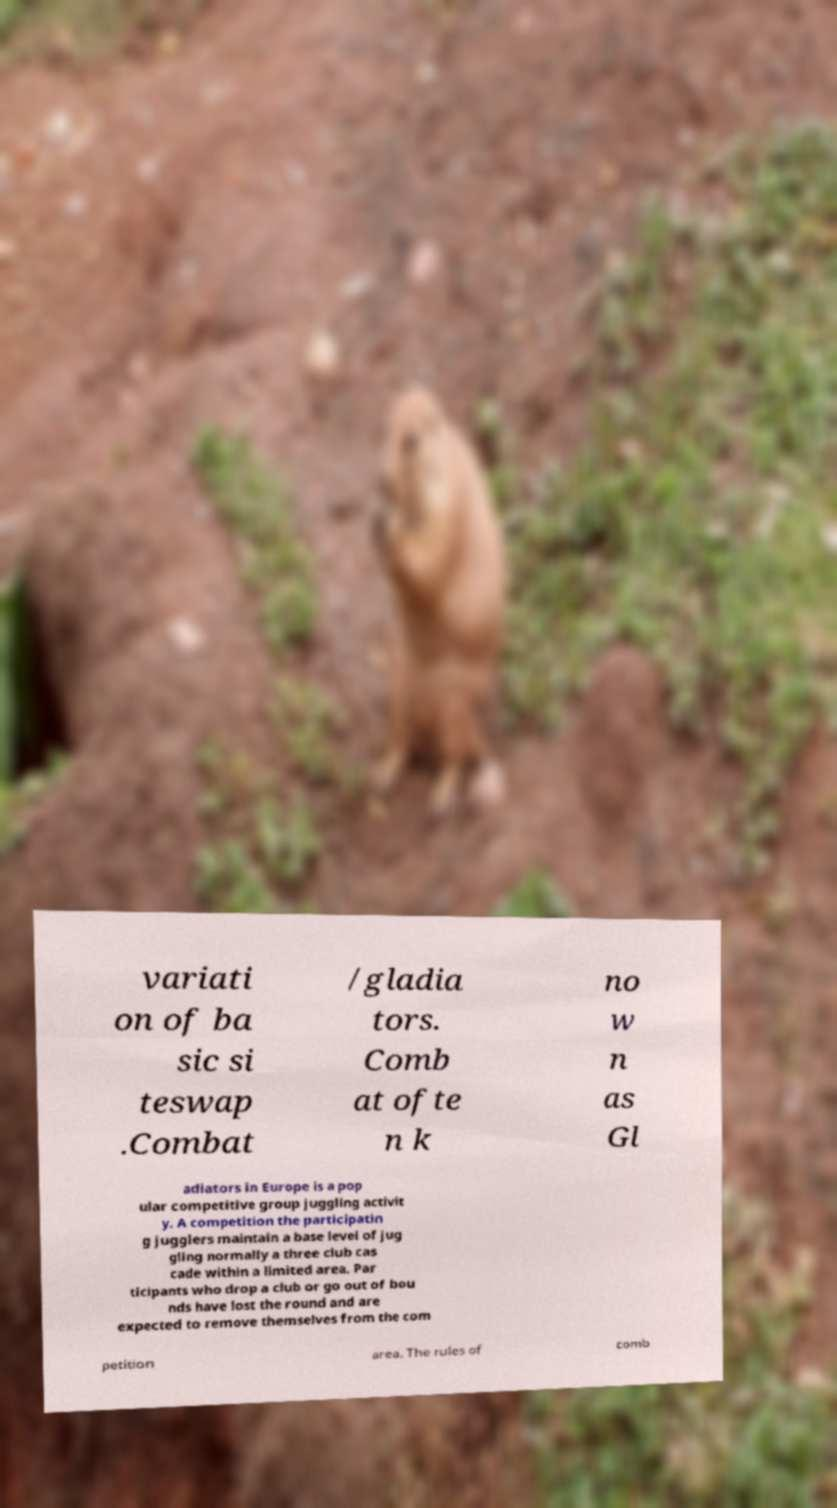Could you assist in decoding the text presented in this image and type it out clearly? variati on of ba sic si teswap .Combat /gladia tors. Comb at ofte n k no w n as Gl adiators in Europe is a pop ular competitive group juggling activit y. A competition the participatin g jugglers maintain a base level of jug gling normally a three club cas cade within a limited area. Par ticipants who drop a club or go out of bou nds have lost the round and are expected to remove themselves from the com petition area. The rules of comb 